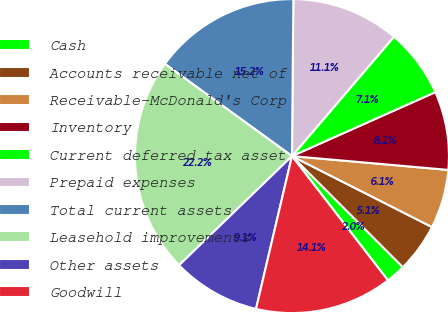<chart> <loc_0><loc_0><loc_500><loc_500><pie_chart><fcel>Cash<fcel>Accounts receivable net of<fcel>Receivable-McDonald's Corp<fcel>Inventory<fcel>Current deferred tax asset<fcel>Prepaid expenses<fcel>Total current assets<fcel>Leasehold improvements<fcel>Other assets<fcel>Goodwill<nl><fcel>2.02%<fcel>5.05%<fcel>6.06%<fcel>8.08%<fcel>7.07%<fcel>11.11%<fcel>15.15%<fcel>22.22%<fcel>9.09%<fcel>14.14%<nl></chart> 